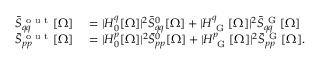Convert formula to latex. <formula><loc_0><loc_0><loc_500><loc_500>\begin{array} { r l } { \bar { S } _ { q q } ^ { o u t } [ \Omega ] } & = | H _ { 0 } ^ { q } [ \Omega ] | ^ { 2 } \bar { S } _ { q q } ^ { 0 } [ \Omega ] + | H _ { G } ^ { q } [ \Omega ] | ^ { 2 } \bar { S } _ { q q } ^ { G } [ \Omega ] } \\ { \bar { S } _ { p p } ^ { o u t } [ \Omega ] } & = | H _ { 0 } ^ { p } [ \Omega ] | ^ { 2 } \bar { S } _ { p p } ^ { 0 } [ \Omega ] + | H _ { G } ^ { p } [ \Omega ] | ^ { 2 } \bar { S } _ { p p } ^ { G } [ \Omega ] . } \end{array}</formula> 